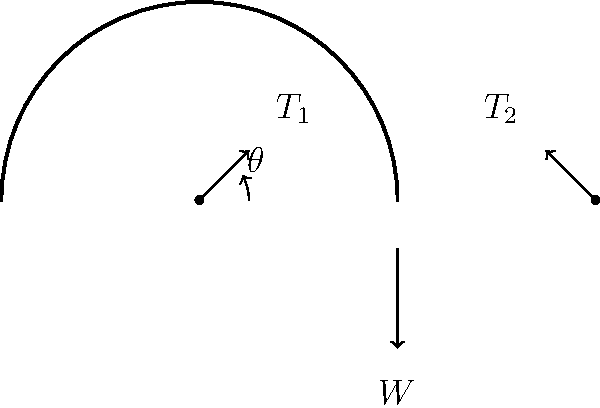A yoga hammock is suspended between two support points, creating a curved shape as shown in the free-body diagram. The weight of a yogi ($W$) is applied at the center of the hammock, and the tension forces in the hammock are represented by $T_1$ and $T_2$. If the angle between the horizontal and the hammock at the support point is $\theta = 30°$, and the weight of the yogi is 600 N, what is the tension force in each side of the hammock? To solve this problem, we'll follow these steps:

1) In a symmetric setup, the tension forces $T_1$ and $T_2$ are equal. Let's call this tension $T$.

2) We can resolve the forces in the vertical direction:
   
   $2T \sin \theta = W$

3) Rearranging this equation:
   
   $T = \frac{W}{2 \sin \theta}$

4) We're given:
   $W = 600$ N
   $\theta = 30°$

5) Substituting these values:
   
   $T = \frac{600}{2 \sin 30°}$

6) $\sin 30° = 0.5$, so:
   
   $T = \frac{600}{2 * 0.5} = \frac{600}{1} = 600$ N

Therefore, the tension in each side of the hammock is 600 N.
Answer: 600 N 